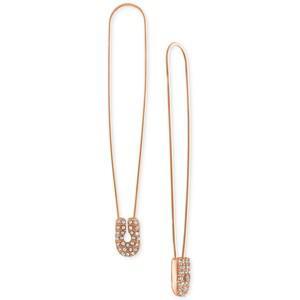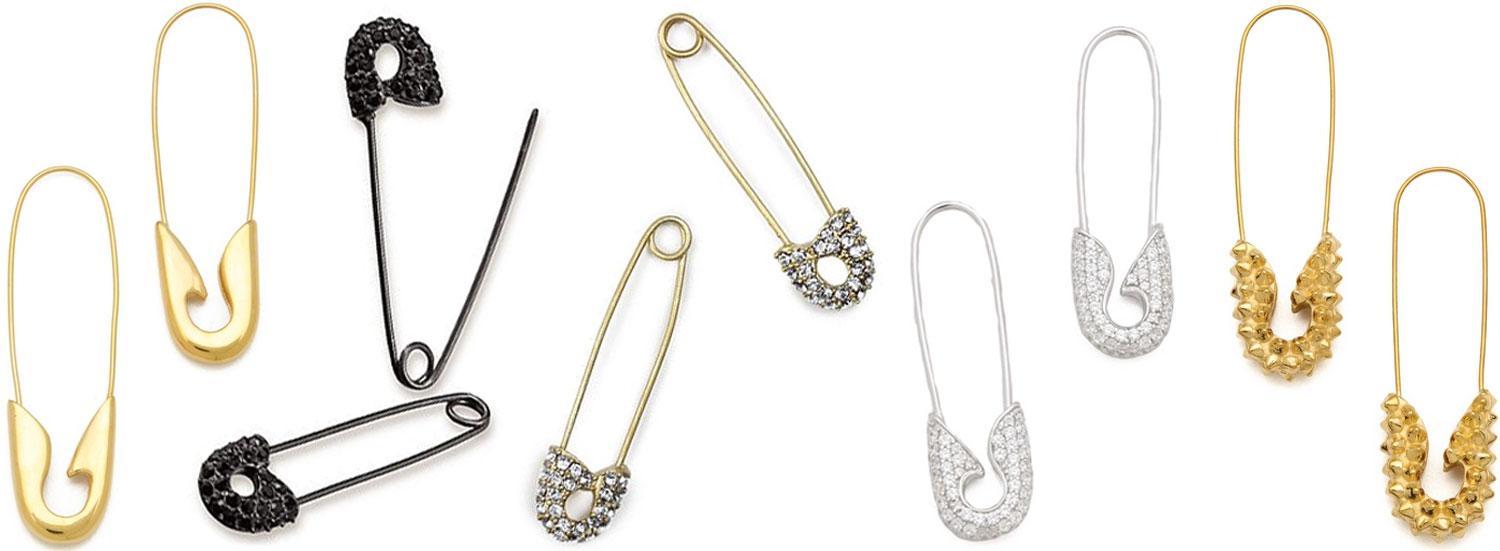The first image is the image on the left, the second image is the image on the right. Examine the images to the left and right. Is the description "The left image contains a women wearing an ear ring." accurate? Answer yes or no. No. The first image is the image on the left, the second image is the image on the right. Assess this claim about the two images: "A person is wearing a safety pin in their ear in the image on the left.". Correct or not? Answer yes or no. No. 